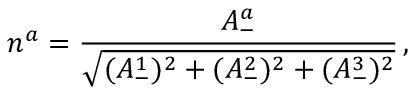<formula> <loc_0><loc_0><loc_500><loc_500>n ^ { a } = \frac { A _ { - } ^ { a } } { \sqrt { ( A _ { - } ^ { 1 } ) ^ { 2 } + ( A _ { - } ^ { 2 } ) ^ { 2 } + ( A _ { - } ^ { 3 } ) ^ { 2 } } } \, ,</formula> 